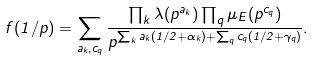<formula> <loc_0><loc_0><loc_500><loc_500>f ( 1 / p ) = \sum _ { a _ { k } , c _ { q } } \frac { \prod _ { k } \lambda ( p ^ { a _ { k } } ) \prod _ { q } \mu _ { E } ( p ^ { c _ { q } } ) } { p ^ { \sum _ { k } a _ { k } ( 1 / 2 + \alpha _ { k } ) + \sum _ { q } c _ { q } ( 1 / 2 + \gamma _ { q } ) } } .</formula> 